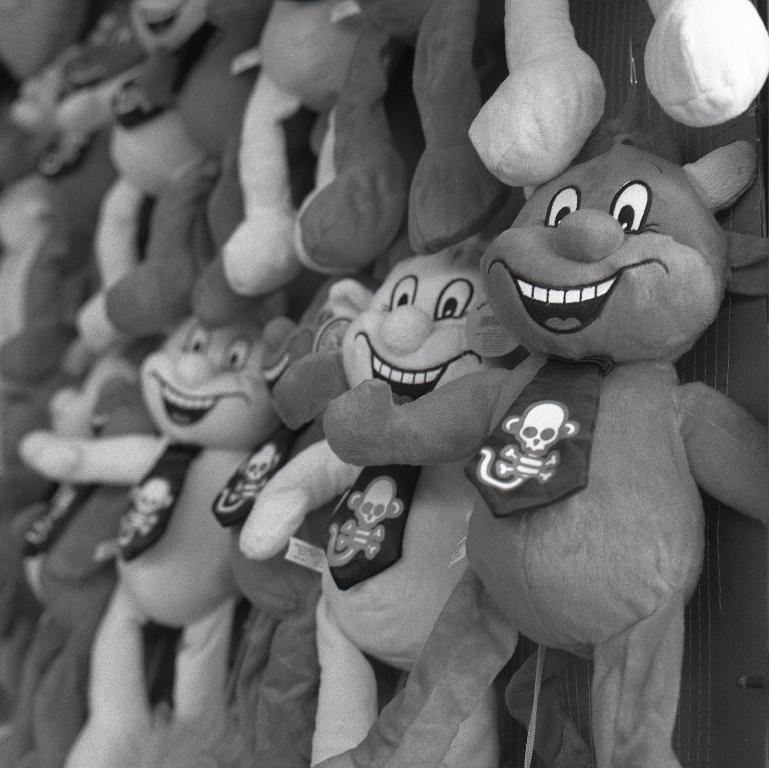What type of objects can be seen in the image? There are soft toys in the image. What is the color scheme of the image? The image is black and white. What type of noise can be heard coming from the soft toys in the image? There is no noise present in the image, as it is a still image and not a video or audio recording. 